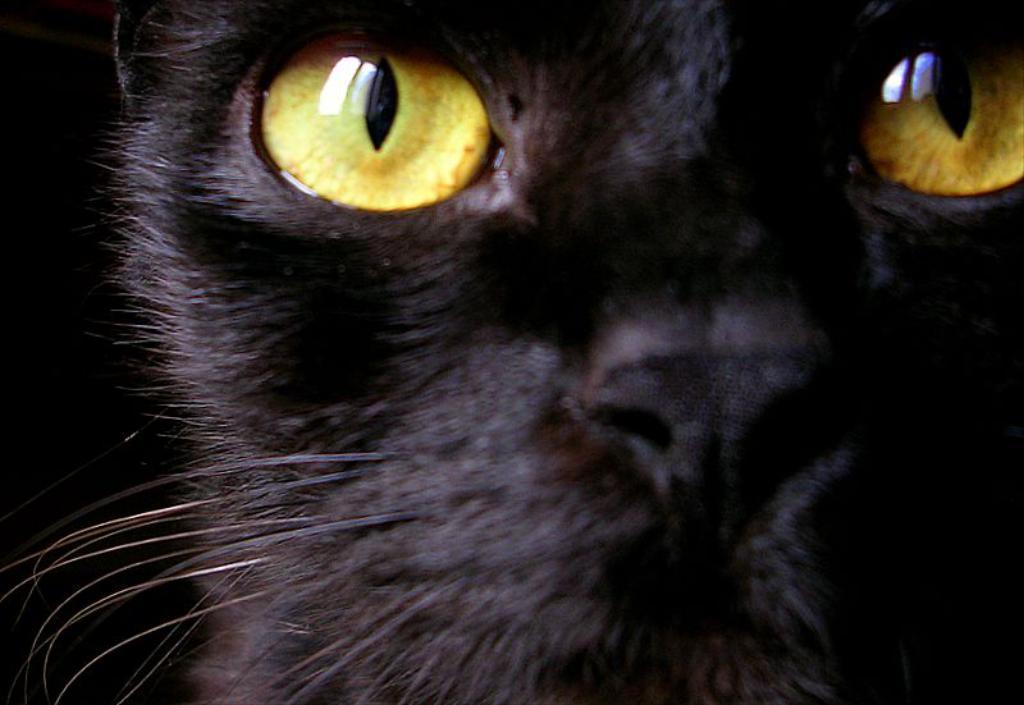Please provide a concise description of this image. In the image we can see there is a black cat and there are yellow eye lens. 